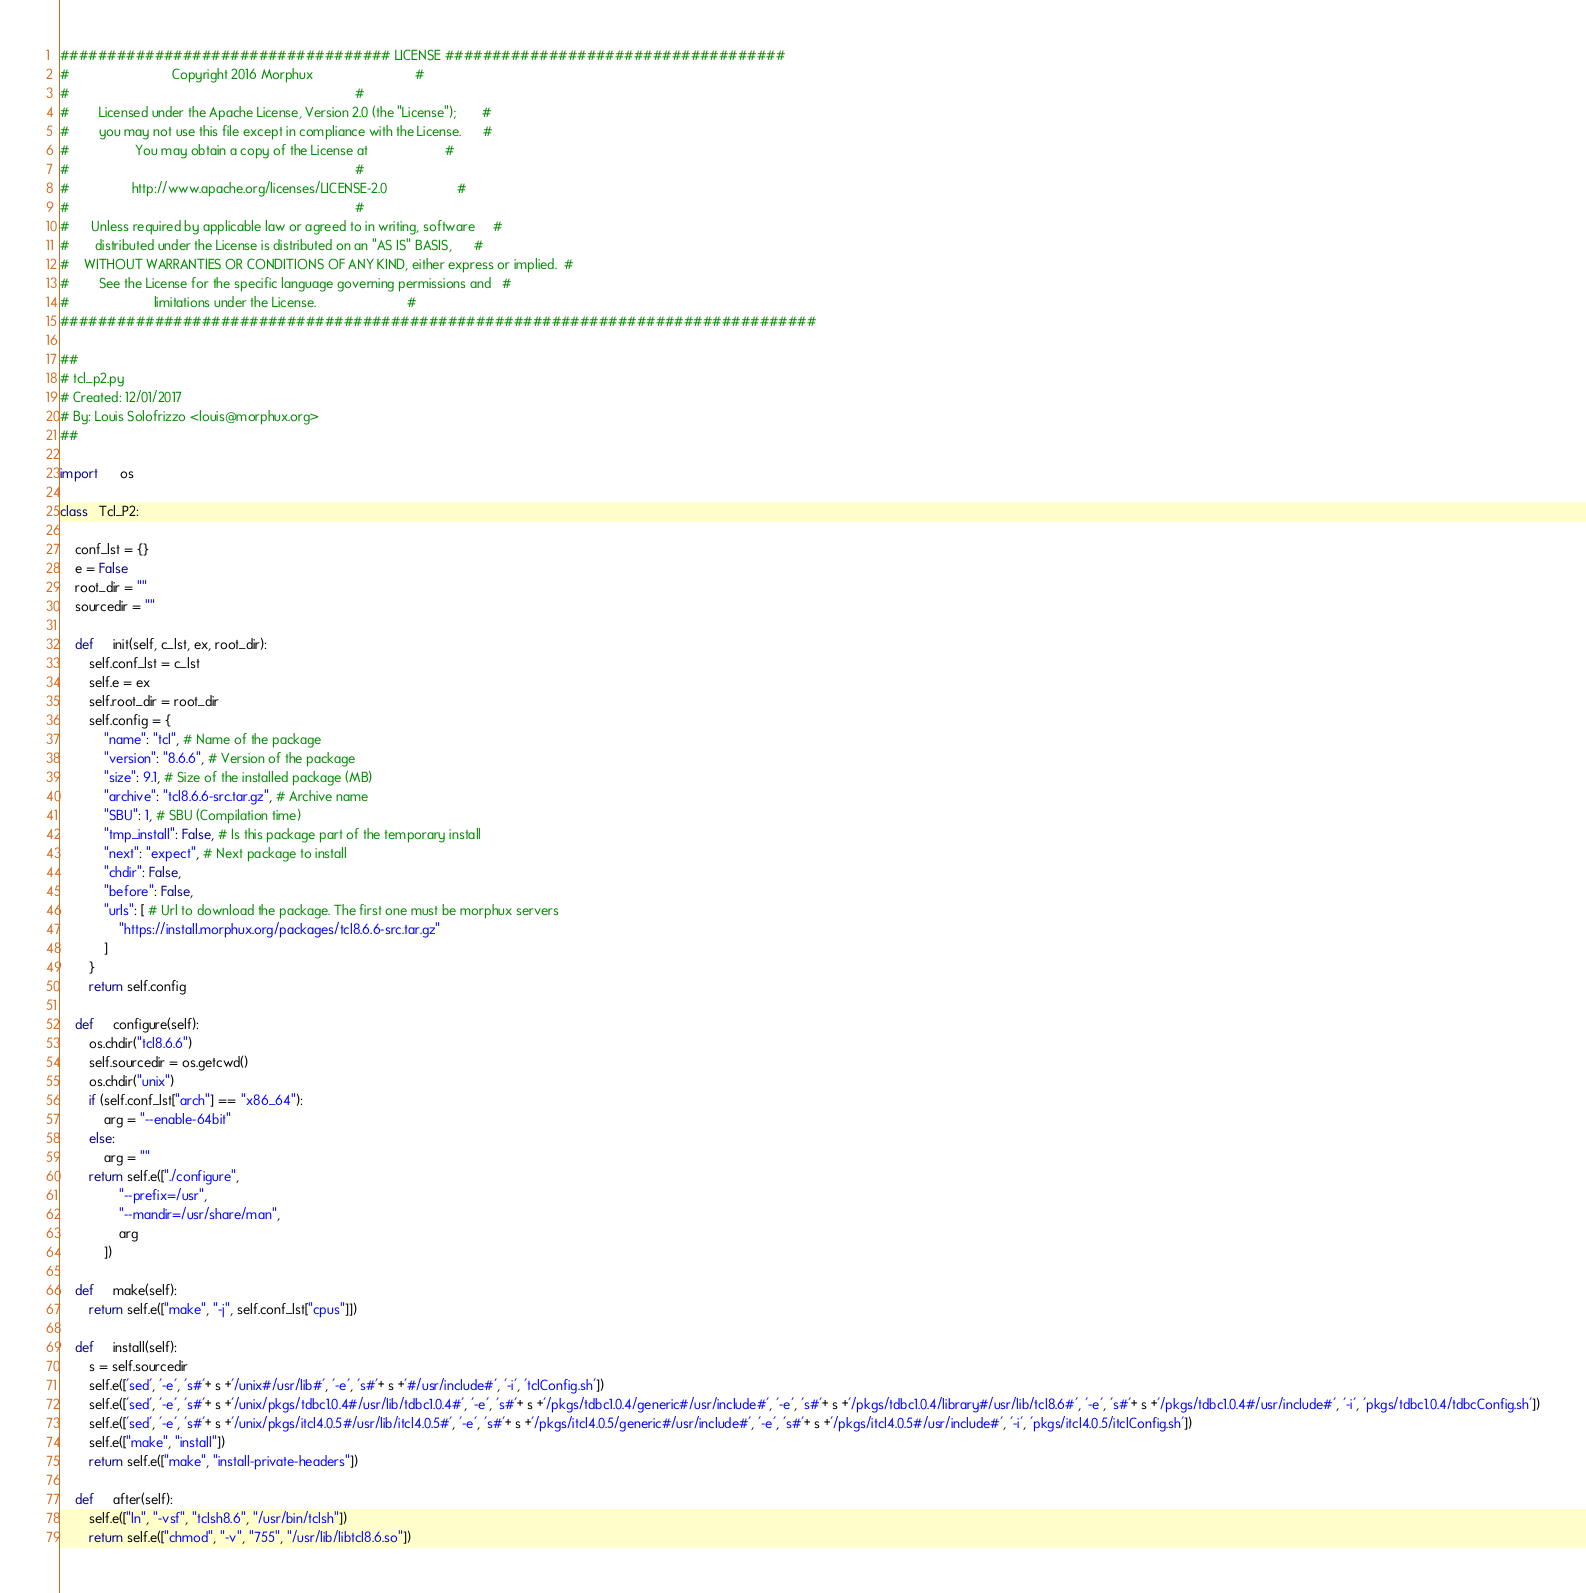<code> <loc_0><loc_0><loc_500><loc_500><_Python_>################################### LICENSE ####################################
#                            Copyright 2016 Morphux                            #
#                                                                              #
#        Licensed under the Apache License, Version 2.0 (the "License");       #
#        you may not use this file except in compliance with the License.      #
#                  You may obtain a copy of the License at                     #
#                                                                              #
#                 http://www.apache.org/licenses/LICENSE-2.0                   #
#                                                                              #
#      Unless required by applicable law or agreed to in writing, software     #
#       distributed under the License is distributed on an "AS IS" BASIS,      #
#    WITHOUT WARRANTIES OR CONDITIONS OF ANY KIND, either express or implied.  #
#        See the License for the specific language governing permissions and   #
#                       limitations under the License.                         #
################################################################################

##
# tcl_p2.py
# Created: 12/01/2017
# By: Louis Solofrizzo <louis@morphux.org>
##

import      os

class   Tcl_P2:

    conf_lst = {}
    e = False
    root_dir = ""
    sourcedir = ""

    def     init(self, c_lst, ex, root_dir):
        self.conf_lst = c_lst
        self.e = ex
        self.root_dir = root_dir
        self.config = {
            "name": "tcl", # Name of the package
            "version": "8.6.6", # Version of the package
            "size": 9.1, # Size of the installed package (MB)
            "archive": "tcl8.6.6-src.tar.gz", # Archive name
            "SBU": 1, # SBU (Compilation time)
            "tmp_install": False, # Is this package part of the temporary install
            "next": "expect", # Next package to install
            "chdir": False,
            "before": False,
            "urls": [ # Url to download the package. The first one must be morphux servers
                "https://install.morphux.org/packages/tcl8.6.6-src.tar.gz"
            ]
        }
        return self.config

    def     configure(self):
        os.chdir("tcl8.6.6")
        self.sourcedir = os.getcwd()
        os.chdir("unix")
        if (self.conf_lst["arch"] == "x86_64"):
            arg = "--enable-64bit"
        else:
            arg = ""
        return self.e(["./configure",
                "--prefix=/usr",
                "--mandir=/usr/share/man",
                arg
            ])

    def     make(self):
        return self.e(["make", "-j", self.conf_lst["cpus"]])

    def     install(self):
        s = self.sourcedir
        self.e(['sed', '-e', 's#'+ s +'/unix#/usr/lib#', '-e', 's#'+ s +'#/usr/include#', '-i', 'tclConfig.sh'])
        self.e(['sed', '-e', 's#'+ s +'/unix/pkgs/tdbc1.0.4#/usr/lib/tdbc1.0.4#', '-e', 's#'+ s +'/pkgs/tdbc1.0.4/generic#/usr/include#', '-e', 's#'+ s +'/pkgs/tdbc1.0.4/library#/usr/lib/tcl8.6#', '-e', 's#'+ s +'/pkgs/tdbc1.0.4#/usr/include#', '-i', 'pkgs/tdbc1.0.4/tdbcConfig.sh'])
        self.e(['sed', '-e', 's#'+ s +'/unix/pkgs/itcl4.0.5#/usr/lib/itcl4.0.5#', '-e', 's#'+ s +'/pkgs/itcl4.0.5/generic#/usr/include#', '-e', 's#'+ s +'/pkgs/itcl4.0.5#/usr/include#', '-i', 'pkgs/itcl4.0.5/itclConfig.sh'])
        self.e(["make", "install"])
        return self.e(["make", "install-private-headers"])

    def     after(self):
        self.e(["ln", "-vsf", "tclsh8.6", "/usr/bin/tclsh"])
        return self.e(["chmod", "-v", "755", "/usr/lib/libtcl8.6.so"])
</code> 